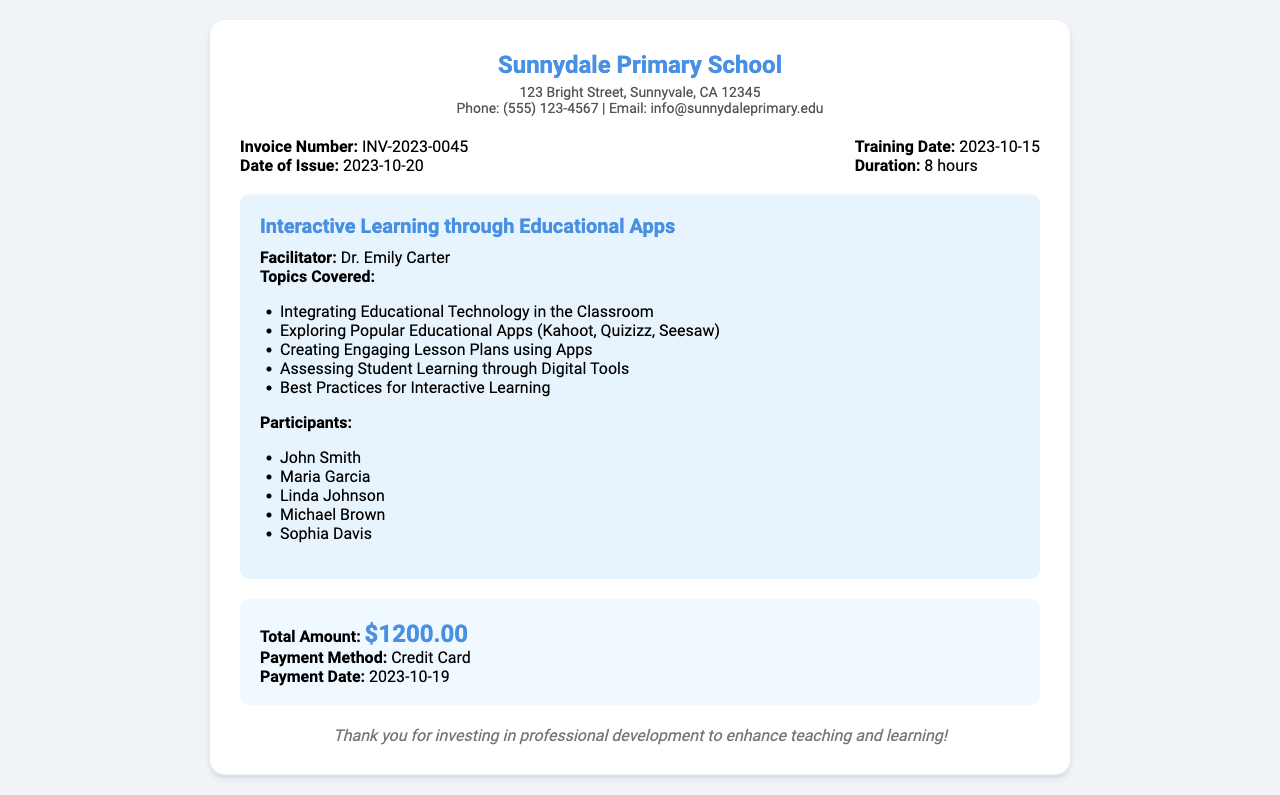What is the invoice number? The invoice number is displayed prominently in the document and is assigned to this transaction.
Answer: INV-2023-0045 Who was the facilitator of the training? The document mentions the name of the facilitator responsible for conducting the training session.
Answer: Dr. Emily Carter What was the total amount paid? The total amount paid is summarized in the document's fees section and denotes the cost of the training.
Answer: $1200.00 How many hours did the training last? The duration of the training is specified clearly within the invoice details.
Answer: 8 hours What was the training date? The date when the training took place is provided in the document under the training details.
Answer: 2023-10-15 List one of the popular educational apps discussed. The document outlines the topics covered during the training, including several specific applications.
Answer: Kahoot How many participants were there? The number of participants is indicated by counting the names listed in the participants section.
Answer: 5 On what date was the payment made? The payment date is detailed in the fees section of the document, denoting when the transaction was completed.
Answer: 2023-10-19 